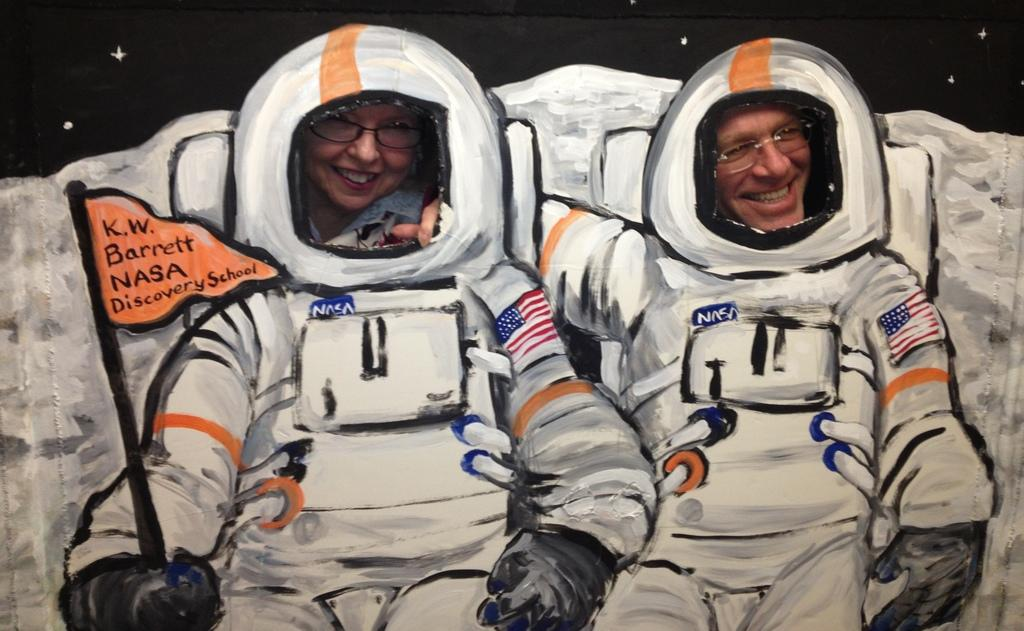What is depicted on the painting that is on the wall? There is a painting of astronauts on the wall. What is unusual about the wall in the image? There are holes in the wall, and heads of people are visible through the wall. What can be seen on the people's faces in the image? The people are wearing glasses (specs). Can you tell me how many rats are visible in the image? There are no rats present in the image. What type of shoes are the rats wearing in the image? There are no rats present in the image, so it is not possible to determine what type of shoes they might be wearing. 